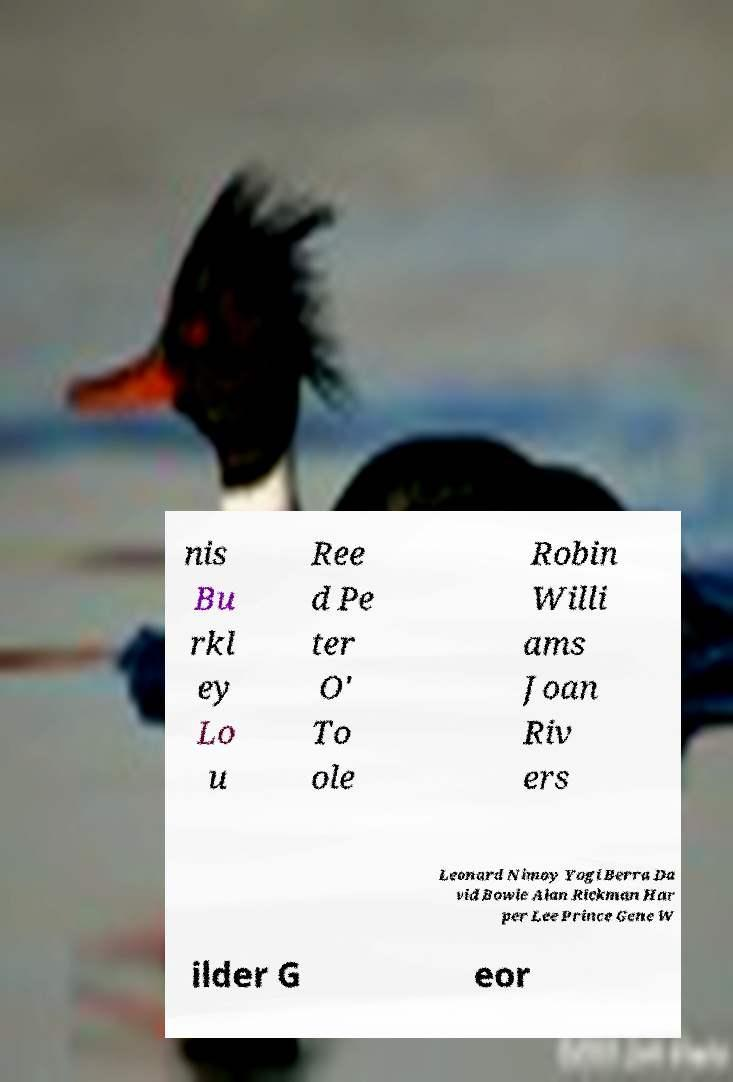Please read and relay the text visible in this image. What does it say? nis Bu rkl ey Lo u Ree d Pe ter O' To ole Robin Willi ams Joan Riv ers Leonard Nimoy Yogi Berra Da vid Bowie Alan Rickman Har per Lee Prince Gene W ilder G eor 